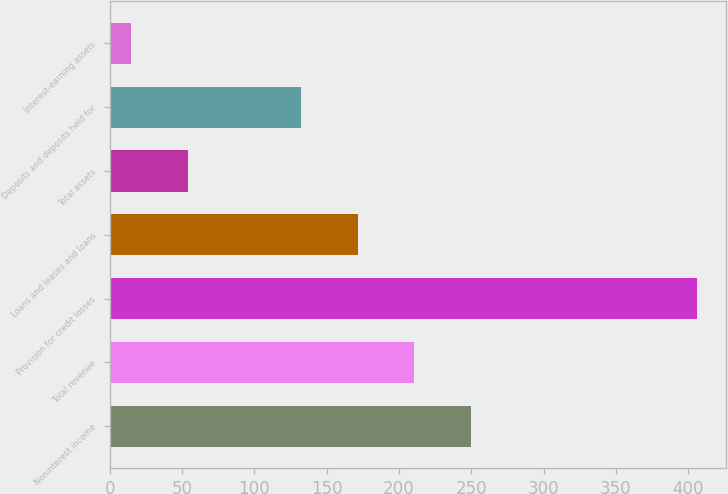Convert chart to OTSL. <chart><loc_0><loc_0><loc_500><loc_500><bar_chart><fcel>Noninterest income<fcel>Total revenue<fcel>Provision for credit losses<fcel>Loans and leases and loans<fcel>Total assets<fcel>Deposits and deposits held for<fcel>Interest-earning assets<nl><fcel>249.6<fcel>210.5<fcel>406<fcel>171.4<fcel>54.1<fcel>132.3<fcel>15<nl></chart> 